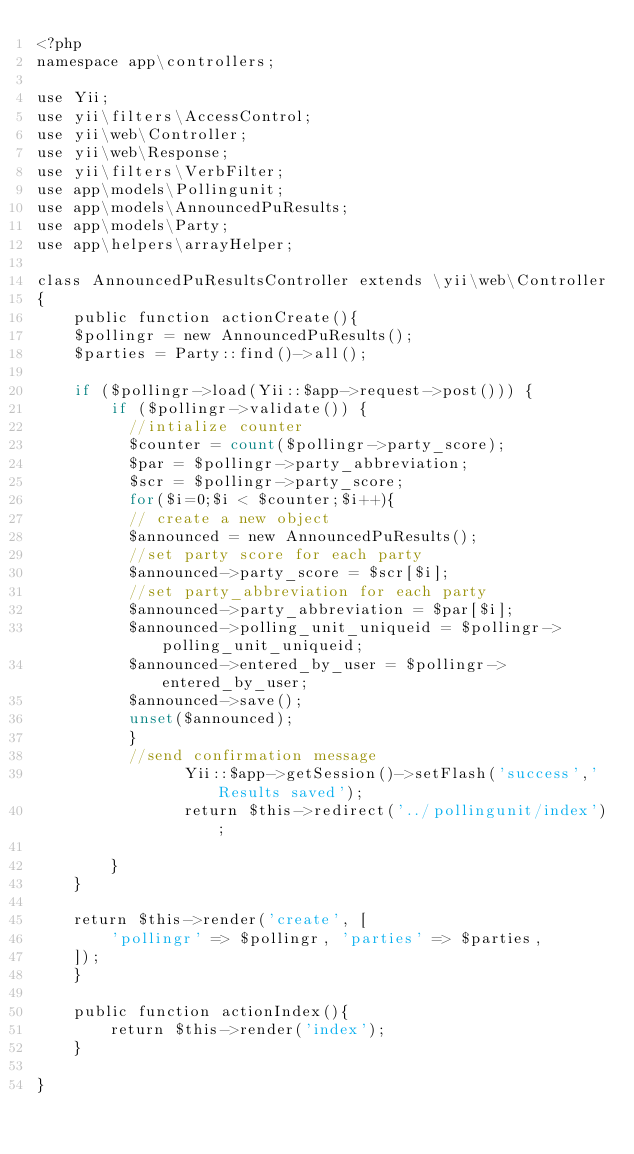Convert code to text. <code><loc_0><loc_0><loc_500><loc_500><_PHP_><?php
namespace app\controllers;

use Yii;
use yii\filters\AccessControl;
use yii\web\Controller;
use yii\web\Response;
use yii\filters\VerbFilter;
use app\models\Pollingunit;
use app\models\AnnouncedPuResults;
use app\models\Party;
use app\helpers\arrayHelper;

class AnnouncedPuResultsController extends \yii\web\Controller
{
    public function actionCreate(){
    $pollingr = new AnnouncedPuResults();
    $parties = Party::find()->all();

    if ($pollingr->load(Yii::$app->request->post())) {
        if ($pollingr->validate()) {
          //intialize counter
          $counter = count($pollingr->party_score);
          $par = $pollingr->party_abbreviation;
          $scr = $pollingr->party_score;
          for($i=0;$i < $counter;$i++){
          // create a new object
          $announced = new AnnouncedPuResults();
          //set party score for each party
          $announced->party_score = $scr[$i];
          //set party_abbreviation for each party
          $announced->party_abbreviation = $par[$i];
          $announced->polling_unit_uniqueid = $pollingr->polling_unit_uniqueid;
          $announced->entered_by_user = $pollingr->entered_by_user;
          $announced->save();
          unset($announced);          
          }
          //send confirmation message 
                Yii::$app->getSession()->setFlash('success','Results saved');
                return $this->redirect('../pollingunit/index');
          
        }
    }

    return $this->render('create', [
        'pollingr' => $pollingr, 'parties' => $parties,
    ]);
    }

    public function actionIndex(){
        return $this->render('index');
    }

}
</code> 